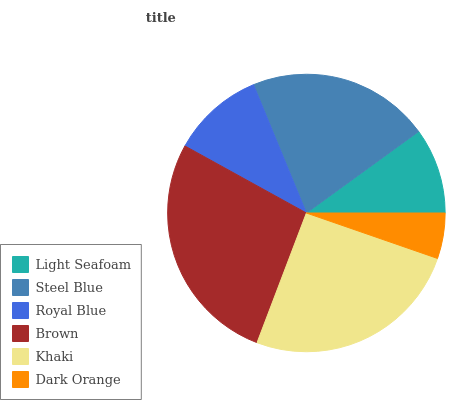Is Dark Orange the minimum?
Answer yes or no. Yes. Is Brown the maximum?
Answer yes or no. Yes. Is Steel Blue the minimum?
Answer yes or no. No. Is Steel Blue the maximum?
Answer yes or no. No. Is Steel Blue greater than Light Seafoam?
Answer yes or no. Yes. Is Light Seafoam less than Steel Blue?
Answer yes or no. Yes. Is Light Seafoam greater than Steel Blue?
Answer yes or no. No. Is Steel Blue less than Light Seafoam?
Answer yes or no. No. Is Steel Blue the high median?
Answer yes or no. Yes. Is Royal Blue the low median?
Answer yes or no. Yes. Is Dark Orange the high median?
Answer yes or no. No. Is Steel Blue the low median?
Answer yes or no. No. 